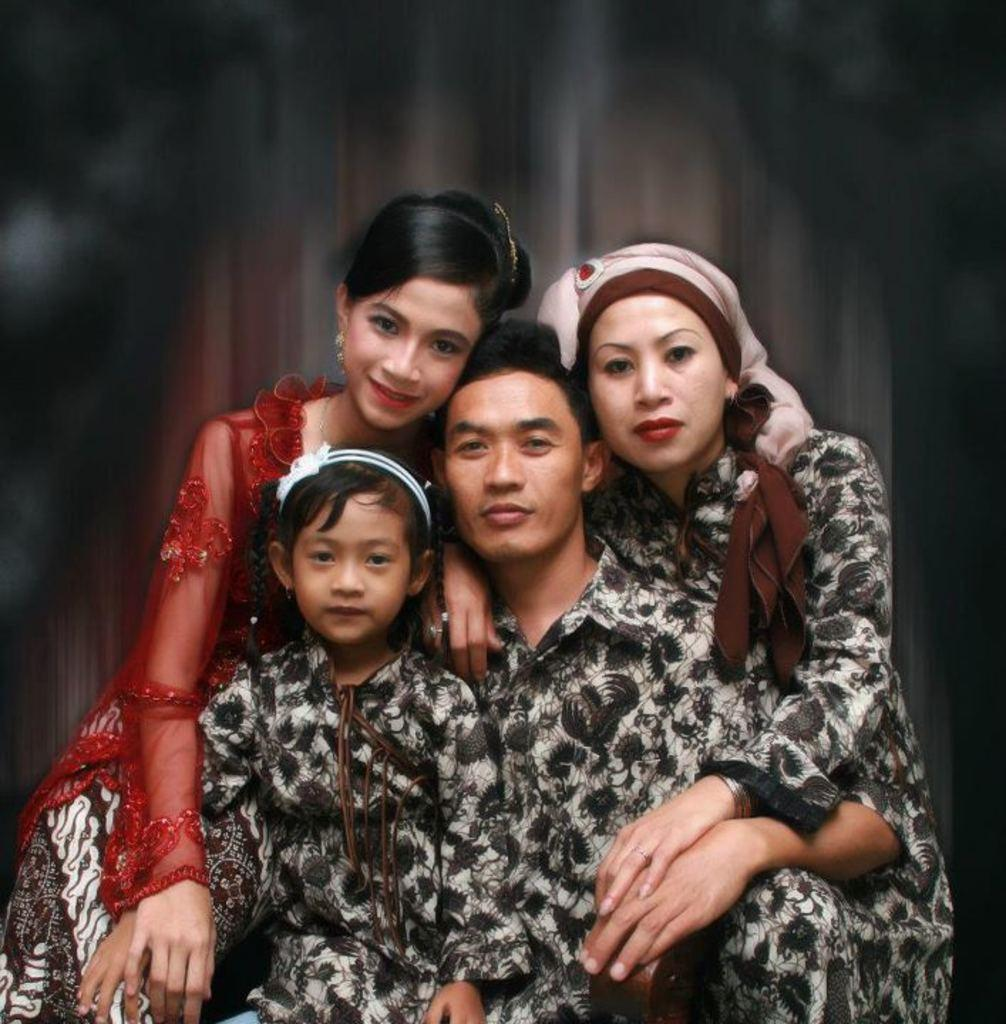What are the people in the image doing? There are persons sitting in the image. Can you see any fog in the image? There is no mention of fog in the provided facts, and therefore it cannot be determined if fog is present in the image. 